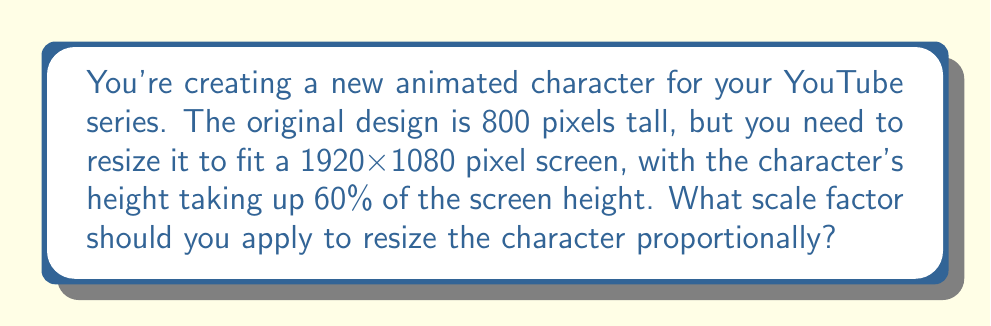Can you solve this math problem? Let's approach this step-by-step:

1) First, we need to determine the target height for the character:
   - The screen height is 1080 pixels
   - The character should take up 60% of this height
   - Target height = $1080 \times 0.60 = 648$ pixels

2) Now we can calculate the scale factor:
   - Scale factor = (New size) / (Original size)
   - In this case: Scale factor = $\frac{\text{Target height}}{\text{Original height}}$

3) Plugging in our values:
   $$ \text{Scale factor} = \frac{648}{800} = 0.81 $$

4) To verify:
   - Original height $\times$ Scale factor = New height
   - $800 \times 0.81 = 648$ pixels

Therefore, to resize the character proportionally to fit 60% of the 1080-pixel screen height, you should apply a scale factor of 0.81 to both the width and height of the original design.
Answer: 0.81 